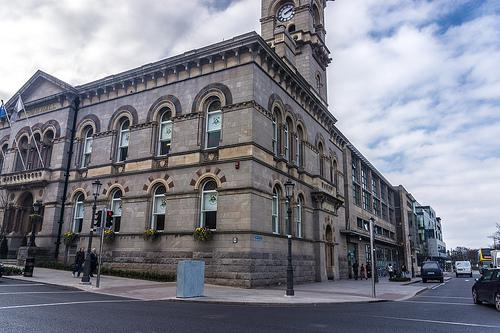Question: how many vehicles are pictured?
Choices:
A. 6.
B. 5.
C. 7.
D. 8.
Answer with the letter. Answer: B Question: what time of day is it?
Choices:
A. Daytime.
B. Nightime.
C. Noon.
D. Dusk.
Answer with the letter. Answer: A Question: how many people are pictured?
Choices:
A. 8.
B. 6.
C. 5.
D. 7.
Answer with the letter. Answer: D Question: where is this picture taken?
Choices:
A. In the house.
B. Outside building.
C. At the park.
D. At the beach.
Answer with the letter. Answer: B 